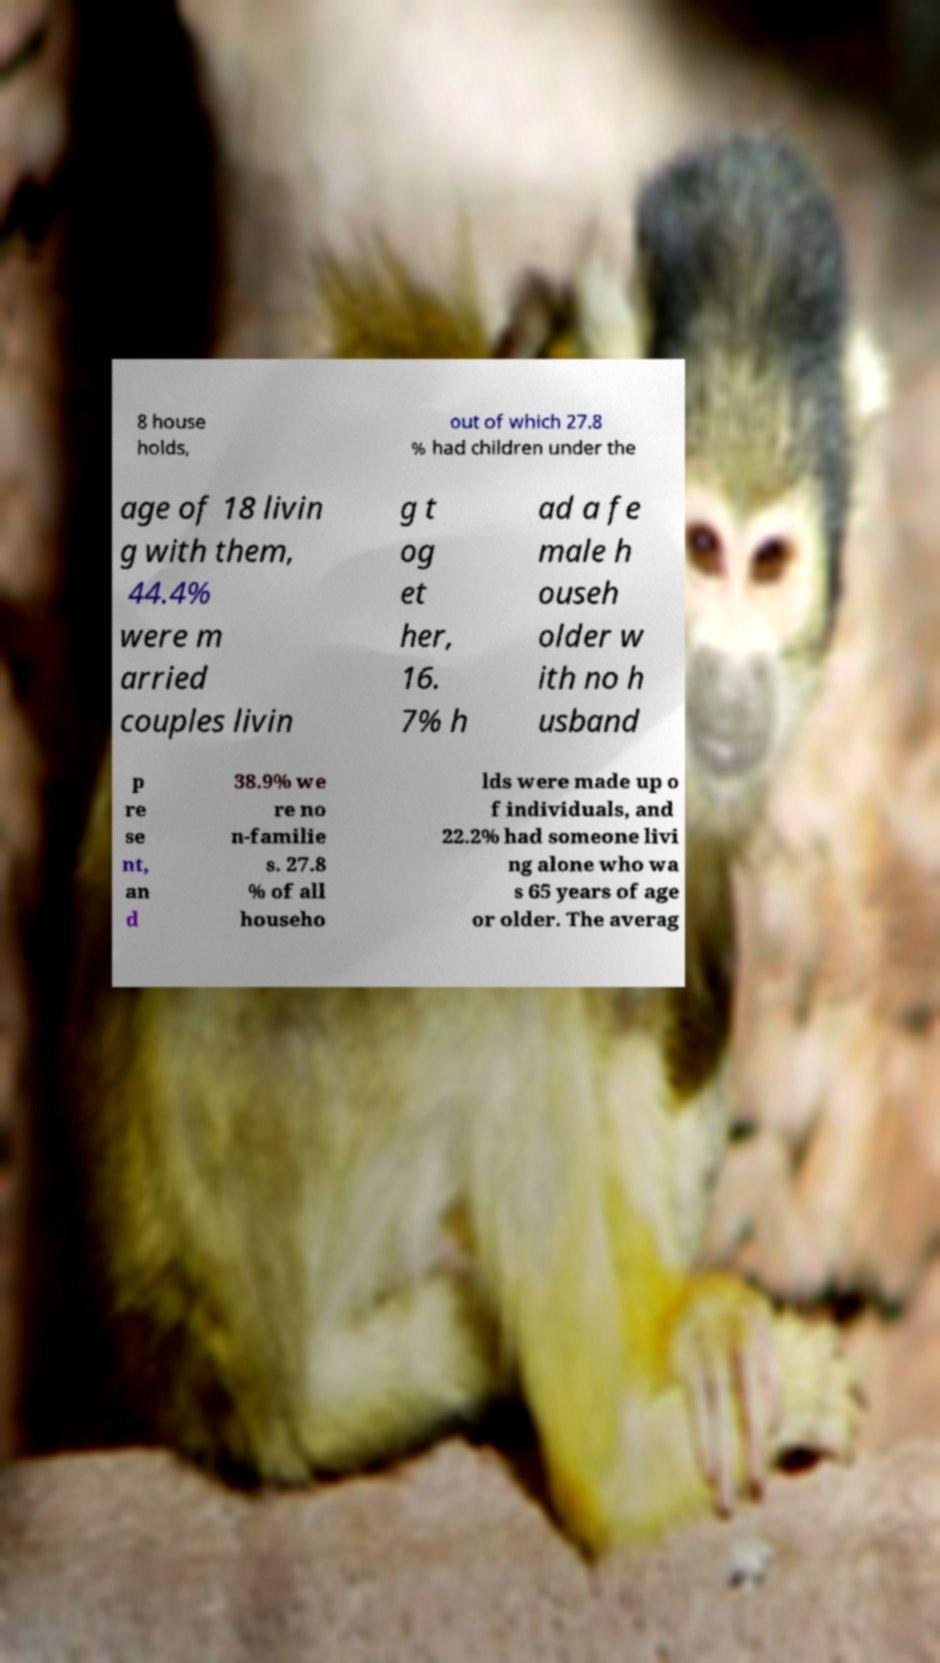Can you accurately transcribe the text from the provided image for me? 8 house holds, out of which 27.8 % had children under the age of 18 livin g with them, 44.4% were m arried couples livin g t og et her, 16. 7% h ad a fe male h ouseh older w ith no h usband p re se nt, an d 38.9% we re no n-familie s. 27.8 % of all househo lds were made up o f individuals, and 22.2% had someone livi ng alone who wa s 65 years of age or older. The averag 